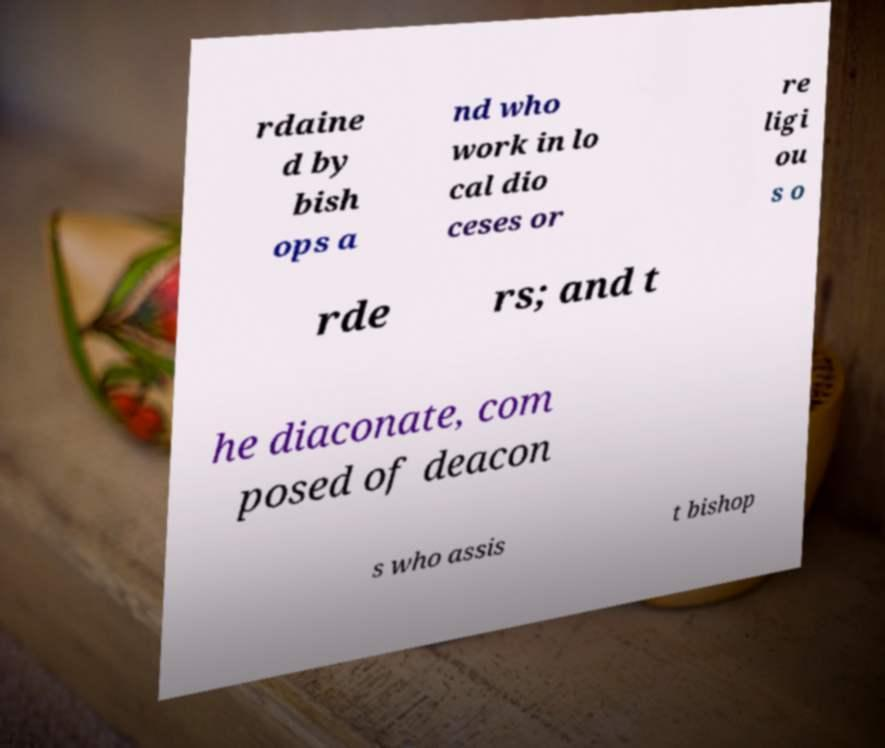I need the written content from this picture converted into text. Can you do that? rdaine d by bish ops a nd who work in lo cal dio ceses or re ligi ou s o rde rs; and t he diaconate, com posed of deacon s who assis t bishop 